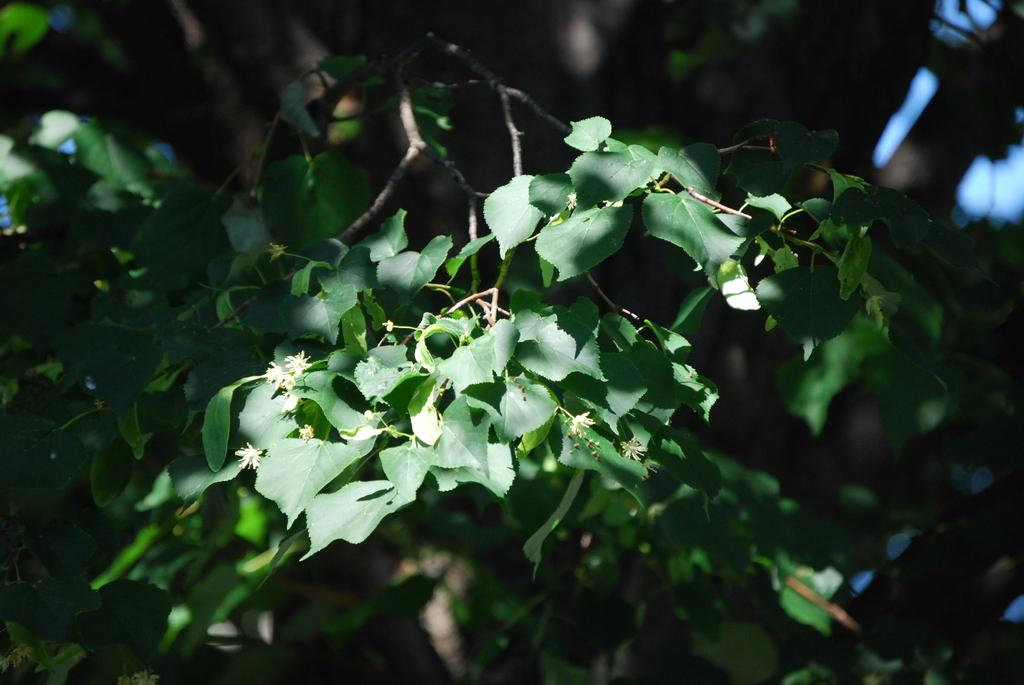What is the main object in the image? There is a branch in the image. Can you describe the background of the image? The background of the image is blurred. What is the chance of finding a stem in the image? There is no mention of a stem in the image, so it's not possible to determine the chance of finding one. 